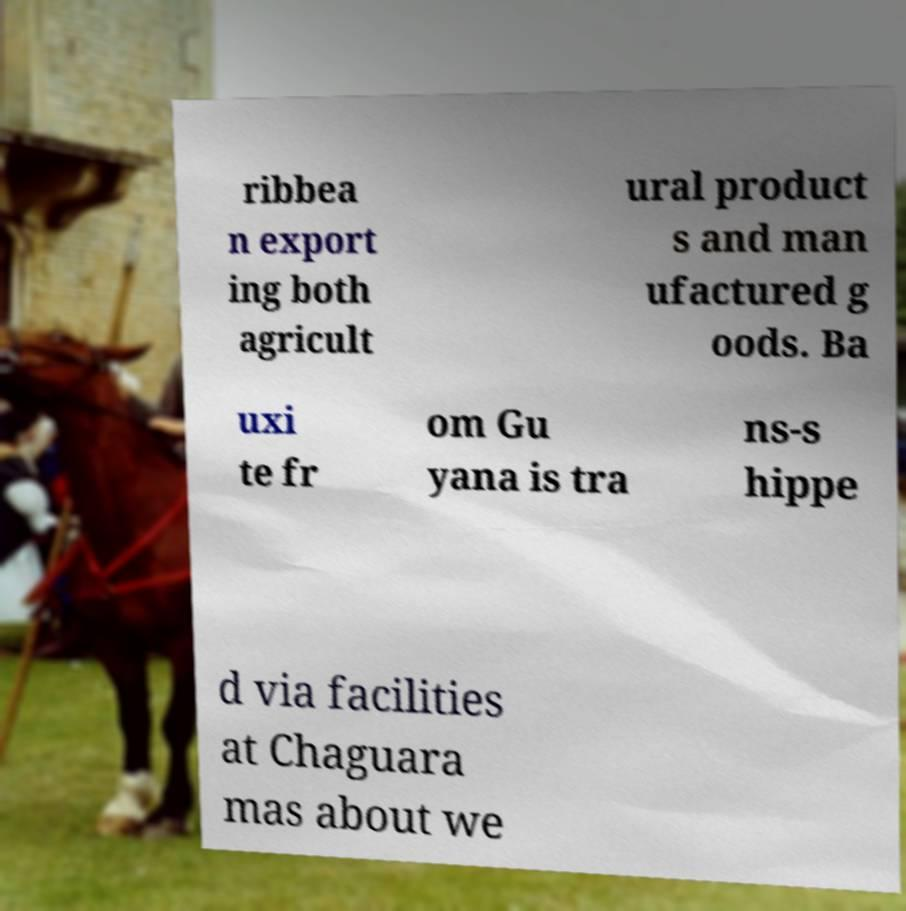There's text embedded in this image that I need extracted. Can you transcribe it verbatim? ribbea n export ing both agricult ural product s and man ufactured g oods. Ba uxi te fr om Gu yana is tra ns-s hippe d via facilities at Chaguara mas about we 